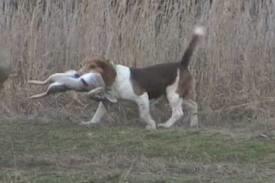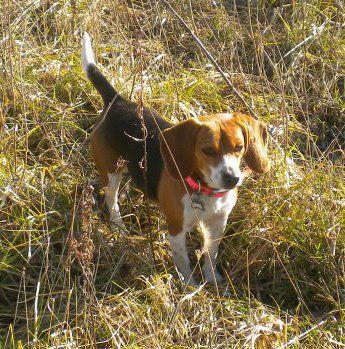The first image is the image on the left, the second image is the image on the right. Given the left and right images, does the statement "There are no more than three animals in the image on the right" hold true? Answer yes or no. Yes. 